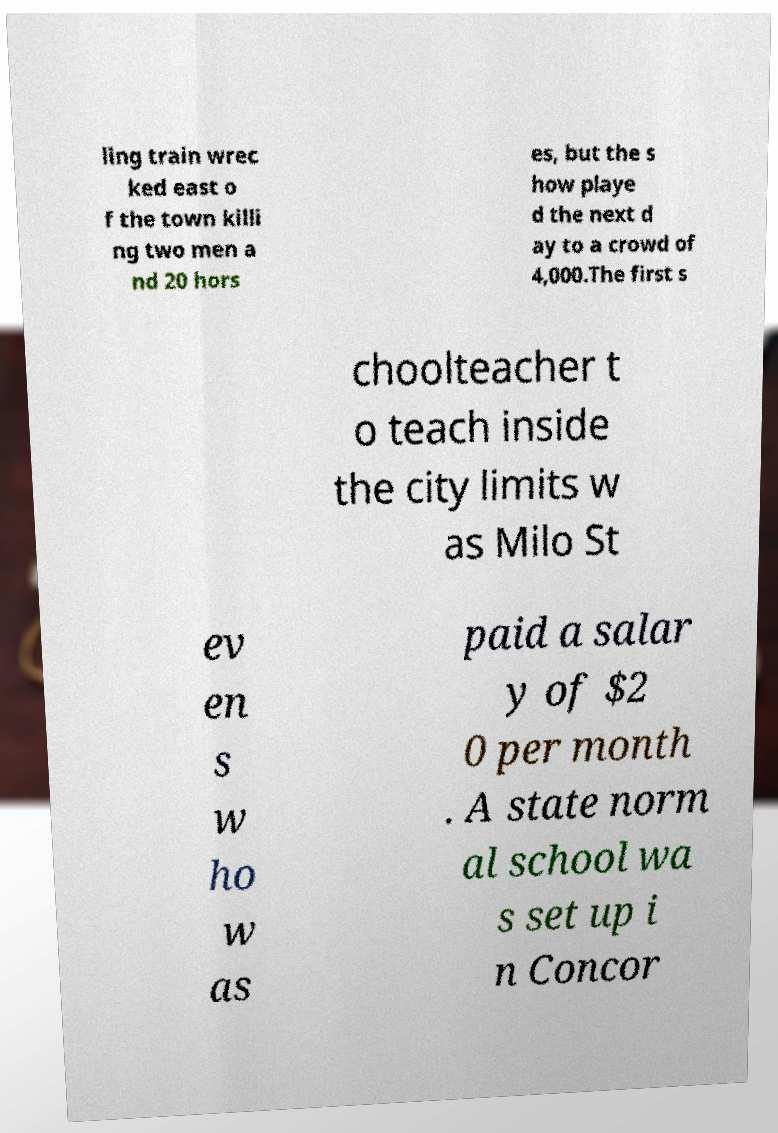I need the written content from this picture converted into text. Can you do that? ling train wrec ked east o f the town killi ng two men a nd 20 hors es, but the s how playe d the next d ay to a crowd of 4,000.The first s choolteacher t o teach inside the city limits w as Milo St ev en s w ho w as paid a salar y of $2 0 per month . A state norm al school wa s set up i n Concor 